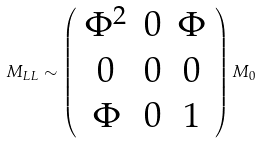Convert formula to latex. <formula><loc_0><loc_0><loc_500><loc_500>M _ { L L } \sim \left ( \begin{array} { c c c } \Phi ^ { 2 } & 0 & \Phi \\ 0 & 0 & 0 \\ \Phi & 0 & 1 \end{array} \right ) M _ { 0 }</formula> 